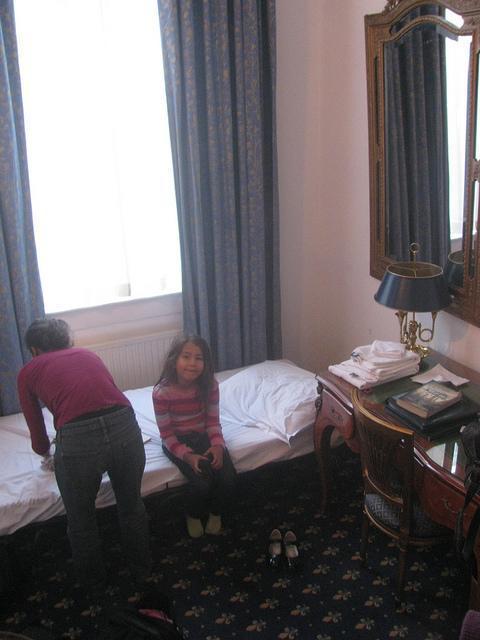Why does she haver her shoes off?
Make your selection and explain in format: 'Answer: answer
Rationale: rationale.'
Options: In bed, too hot, confused, dislikes shoes. Answer: in bed.
Rationale: People take their shoes off in bed. 